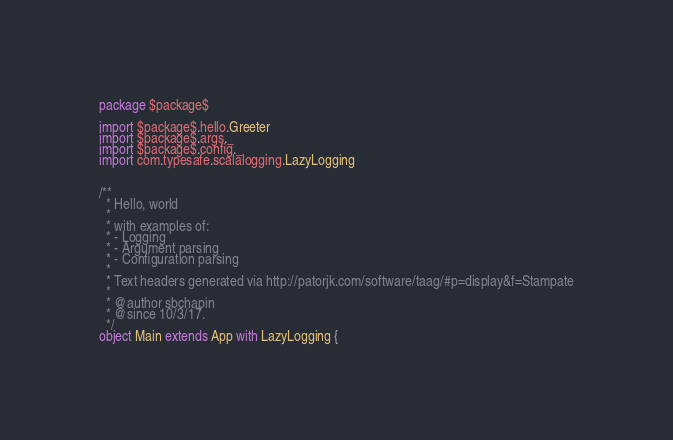Convert code to text. <code><loc_0><loc_0><loc_500><loc_500><_Scala_>package $package$

import $package$.hello.Greeter
import $package$.args._
import $package$.config._
import com.typesafe.scalalogging.LazyLogging


/**
  * Hello, world
  *
  * with examples of:
  * - Logging
  * - Argument parsing
  * - Configuration parsing
  *
  * Text headers generated via http://patorjk.com/software/taag/#p=display&f=Stampate
  *
  * @author sbchapin
  * @since 10/3/17.
  */
object Main extends App with LazyLogging {


</code> 